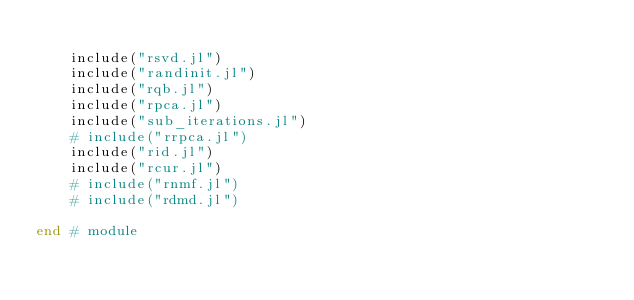<code> <loc_0><loc_0><loc_500><loc_500><_Julia_>
    include("rsvd.jl")
    include("randinit.jl")
    include("rqb.jl")
    include("rpca.jl")
    include("sub_iterations.jl")
    # include("rrpca.jl")
    include("rid.jl")
    include("rcur.jl")
    # include("rnmf.jl")
    # include("rdmd.jl")

end # module
</code> 